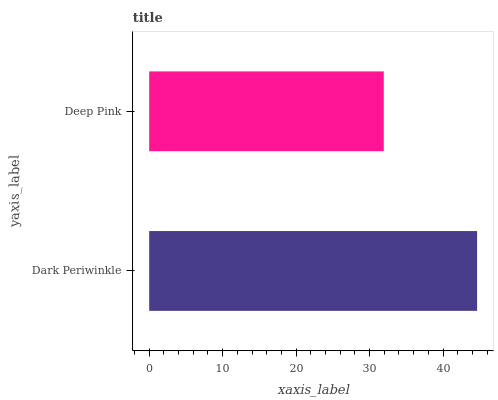Is Deep Pink the minimum?
Answer yes or no. Yes. Is Dark Periwinkle the maximum?
Answer yes or no. Yes. Is Deep Pink the maximum?
Answer yes or no. No. Is Dark Periwinkle greater than Deep Pink?
Answer yes or no. Yes. Is Deep Pink less than Dark Periwinkle?
Answer yes or no. Yes. Is Deep Pink greater than Dark Periwinkle?
Answer yes or no. No. Is Dark Periwinkle less than Deep Pink?
Answer yes or no. No. Is Dark Periwinkle the high median?
Answer yes or no. Yes. Is Deep Pink the low median?
Answer yes or no. Yes. Is Deep Pink the high median?
Answer yes or no. No. Is Dark Periwinkle the low median?
Answer yes or no. No. 